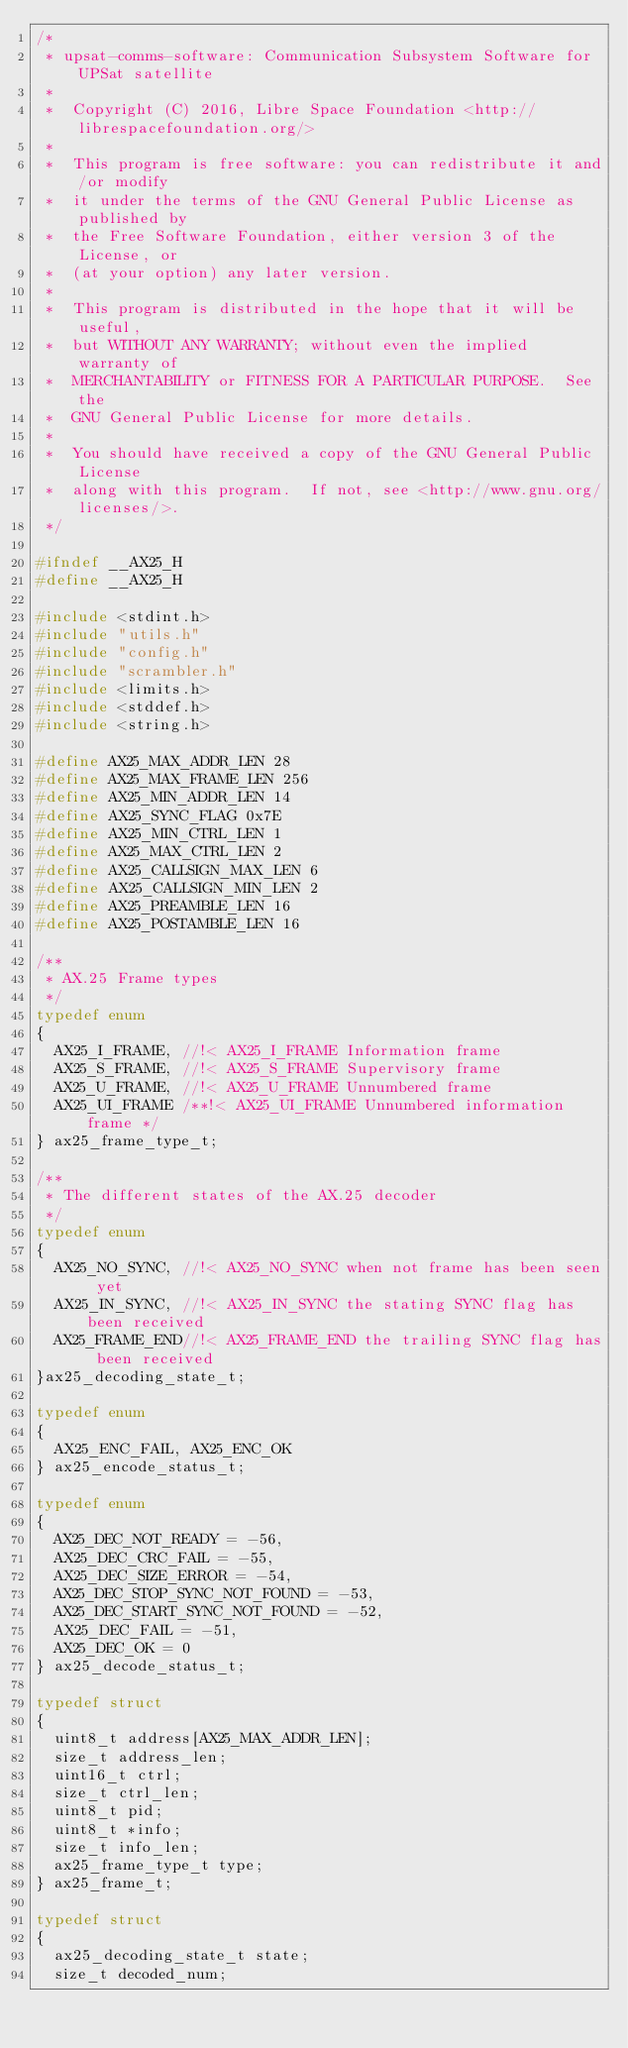Convert code to text. <code><loc_0><loc_0><loc_500><loc_500><_C_>/*
 * upsat-comms-software: Communication Subsystem Software for UPSat satellite
 *
 *  Copyright (C) 2016, Libre Space Foundation <http://librespacefoundation.org/>
 *
 *  This program is free software: you can redistribute it and/or modify
 *  it under the terms of the GNU General Public License as published by
 *  the Free Software Foundation, either version 3 of the License, or
 *  (at your option) any later version.
 *
 *  This program is distributed in the hope that it will be useful,
 *  but WITHOUT ANY WARRANTY; without even the implied warranty of
 *  MERCHANTABILITY or FITNESS FOR A PARTICULAR PURPOSE.  See the
 *  GNU General Public License for more details.
 *
 *  You should have received a copy of the GNU General Public License
 *  along with this program.  If not, see <http://www.gnu.org/licenses/>.
 */

#ifndef __AX25_H
#define __AX25_H

#include <stdint.h>
#include "utils.h"
#include "config.h"
#include "scrambler.h"
#include <limits.h>
#include <stddef.h>
#include <string.h>

#define AX25_MAX_ADDR_LEN 28
#define AX25_MAX_FRAME_LEN 256
#define AX25_MIN_ADDR_LEN 14
#define AX25_SYNC_FLAG 0x7E
#define AX25_MIN_CTRL_LEN 1
#define AX25_MAX_CTRL_LEN 2
#define AX25_CALLSIGN_MAX_LEN 6
#define AX25_CALLSIGN_MIN_LEN 2
#define AX25_PREAMBLE_LEN 16
#define AX25_POSTAMBLE_LEN 16

/**
 * AX.25 Frame types
 */
typedef enum
{
  AX25_I_FRAME, //!< AX25_I_FRAME Information frame
  AX25_S_FRAME, //!< AX25_S_FRAME Supervisory frame
  AX25_U_FRAME, //!< AX25_U_FRAME Unnumbered frame
  AX25_UI_FRAME /**!< AX25_UI_FRAME Unnumbered information frame */
} ax25_frame_type_t;

/**
 * The different states of the AX.25 decoder
 */
typedef enum
{
  AX25_NO_SYNC, //!< AX25_NO_SYNC when not frame has been seen yet
  AX25_IN_SYNC, //!< AX25_IN_SYNC the stating SYNC flag has been received
  AX25_FRAME_END//!< AX25_FRAME_END the trailing SYNC flag has been received
}ax25_decoding_state_t;

typedef enum
{
  AX25_ENC_FAIL, AX25_ENC_OK
} ax25_encode_status_t;

typedef enum
{
  AX25_DEC_NOT_READY = -56,
  AX25_DEC_CRC_FAIL = -55,
  AX25_DEC_SIZE_ERROR = -54,
  AX25_DEC_STOP_SYNC_NOT_FOUND = -53,
  AX25_DEC_START_SYNC_NOT_FOUND = -52,
  AX25_DEC_FAIL = -51,
  AX25_DEC_OK = 0
} ax25_decode_status_t;

typedef struct
{
  uint8_t address[AX25_MAX_ADDR_LEN];
  size_t address_len;
  uint16_t ctrl;
  size_t ctrl_len;
  uint8_t pid;
  uint8_t *info;
  size_t info_len;
  ax25_frame_type_t type;
} ax25_frame_t;

typedef struct
{
  ax25_decoding_state_t state;
  size_t decoded_num;</code> 